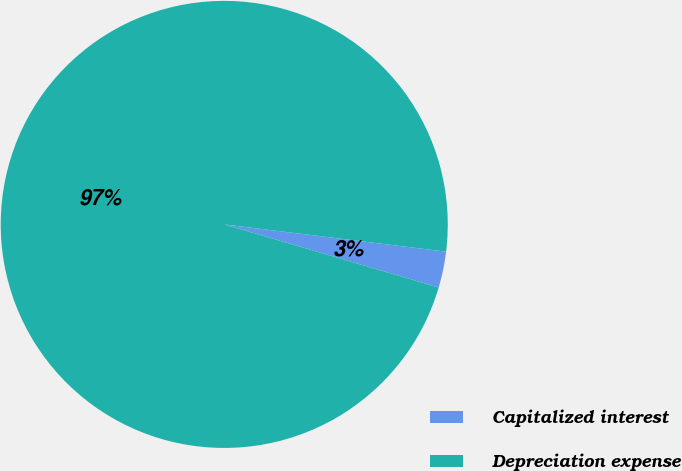<chart> <loc_0><loc_0><loc_500><loc_500><pie_chart><fcel>Capitalized interest<fcel>Depreciation expense<nl><fcel>2.61%<fcel>97.39%<nl></chart> 